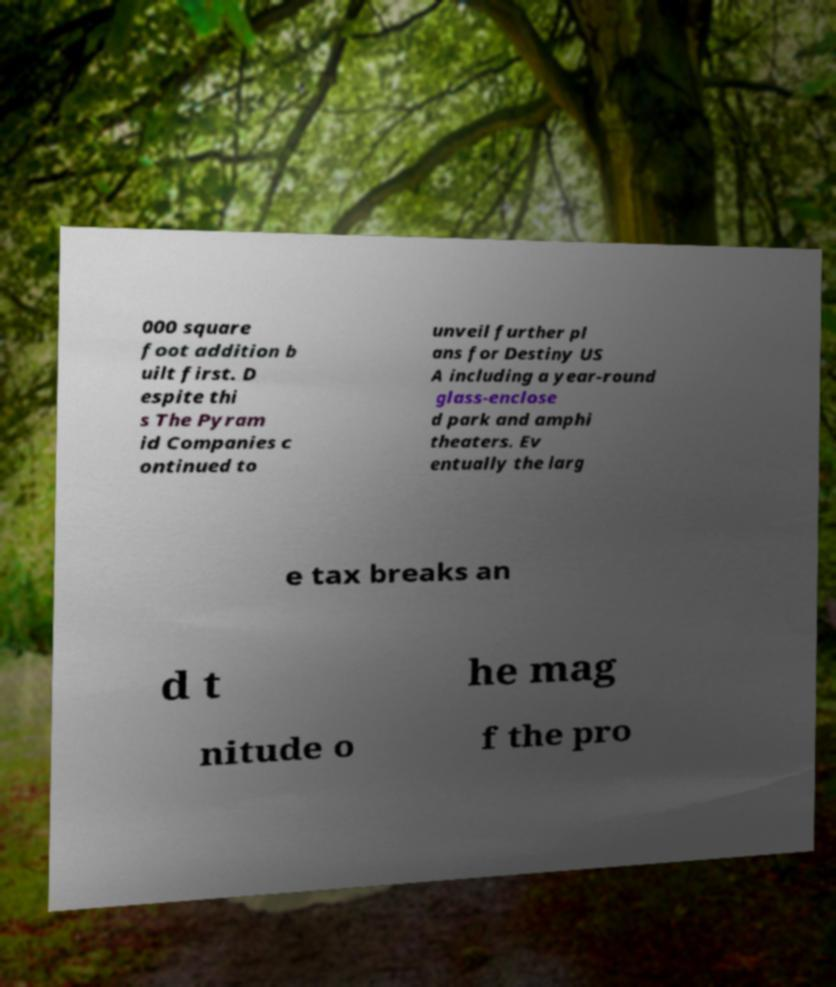I need the written content from this picture converted into text. Can you do that? 000 square foot addition b uilt first. D espite thi s The Pyram id Companies c ontinued to unveil further pl ans for Destiny US A including a year-round glass-enclose d park and amphi theaters. Ev entually the larg e tax breaks an d t he mag nitude o f the pro 